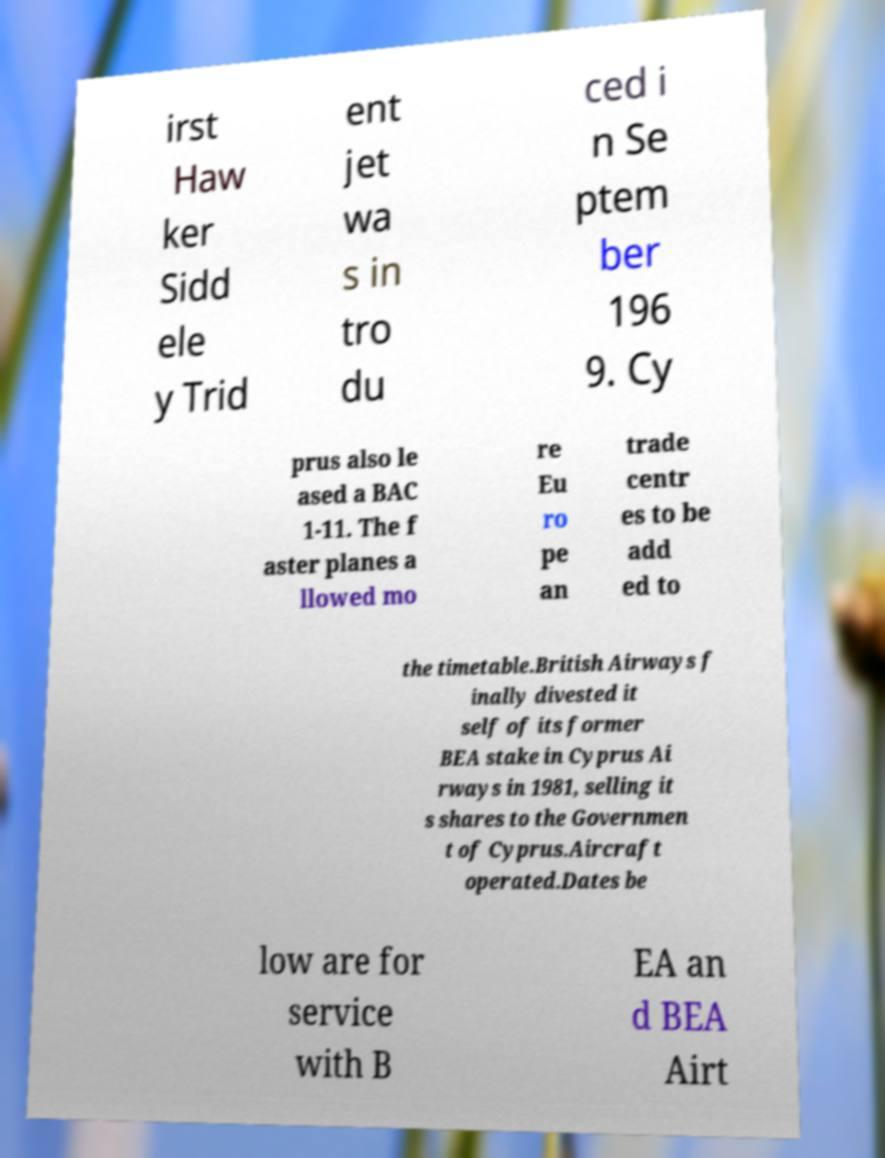Can you accurately transcribe the text from the provided image for me? irst Haw ker Sidd ele y Trid ent jet wa s in tro du ced i n Se ptem ber 196 9. Cy prus also le ased a BAC 1-11. The f aster planes a llowed mo re Eu ro pe an trade centr es to be add ed to the timetable.British Airways f inally divested it self of its former BEA stake in Cyprus Ai rways in 1981, selling it s shares to the Governmen t of Cyprus.Aircraft operated.Dates be low are for service with B EA an d BEA Airt 